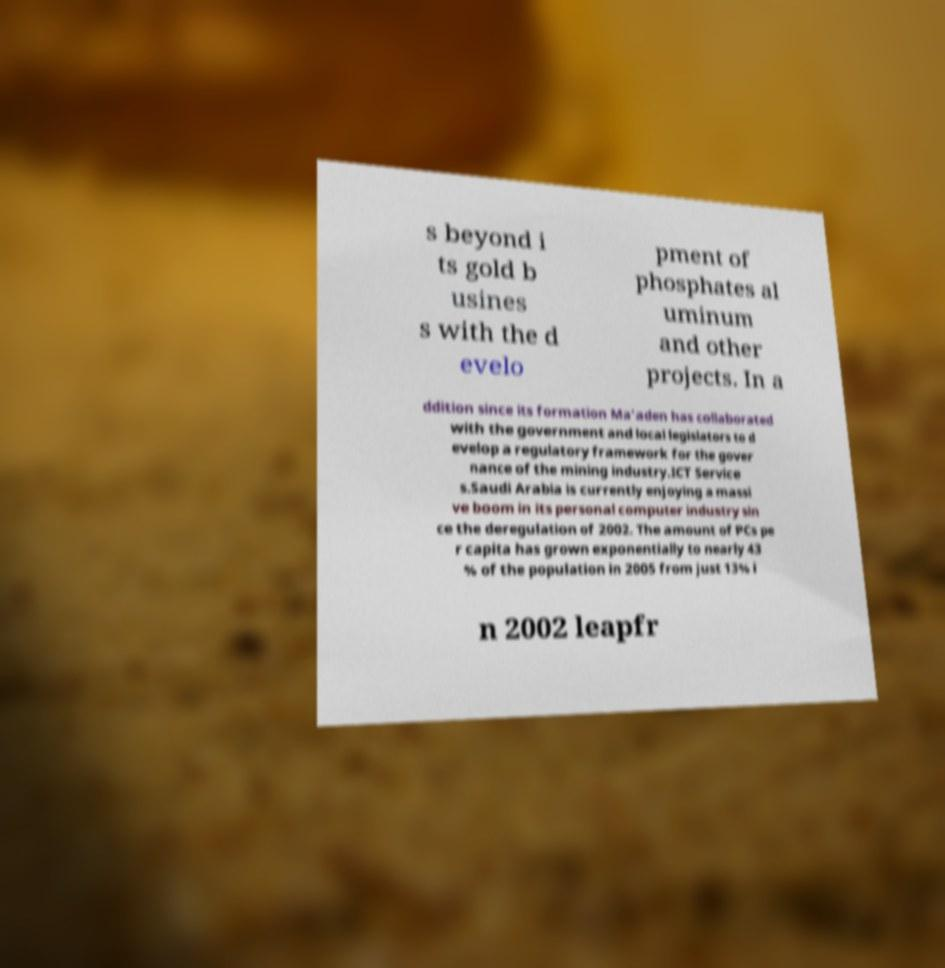I need the written content from this picture converted into text. Can you do that? s beyond i ts gold b usines s with the d evelo pment of phosphates al uminum and other projects. In a ddition since its formation Ma'aden has collaborated with the government and local legislators to d evelop a regulatory framework for the gover nance of the mining industry.ICT Service s.Saudi Arabia is currently enjoying a massi ve boom in its personal computer industry sin ce the deregulation of 2002. The amount of PCs pe r capita has grown exponentially to nearly 43 % of the population in 2005 from just 13% i n 2002 leapfr 